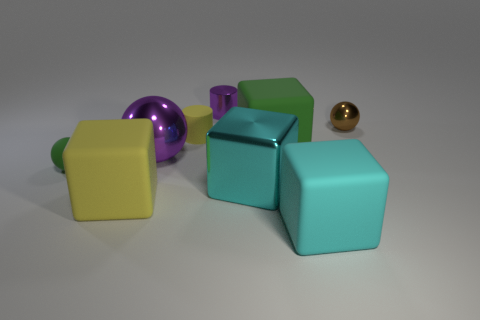The big purple metallic thing is what shape?
Your response must be concise. Sphere. What is the cyan thing that is left of the green object behind the tiny green matte thing made of?
Your answer should be very brief. Metal. How many other things are there of the same material as the big purple sphere?
Your answer should be compact. 3. There is a green thing that is the same size as the cyan metallic thing; what material is it?
Ensure brevity in your answer.  Rubber. Is the number of tiny yellow matte things right of the small yellow matte cylinder greater than the number of yellow rubber things that are to the right of the cyan metallic object?
Your answer should be very brief. No. Are there any large red rubber things of the same shape as the tiny brown metal object?
Make the answer very short. No. What is the shape of the brown metal thing that is the same size as the rubber cylinder?
Ensure brevity in your answer.  Sphere. There is a big cyan thing that is in front of the metal block; what shape is it?
Keep it short and to the point. Cube. Are there fewer green objects that are behind the green matte ball than large cyan blocks that are right of the yellow cylinder?
Provide a short and direct response. Yes. Does the purple metallic cylinder have the same size as the purple thing in front of the large green cube?
Offer a terse response. No. 